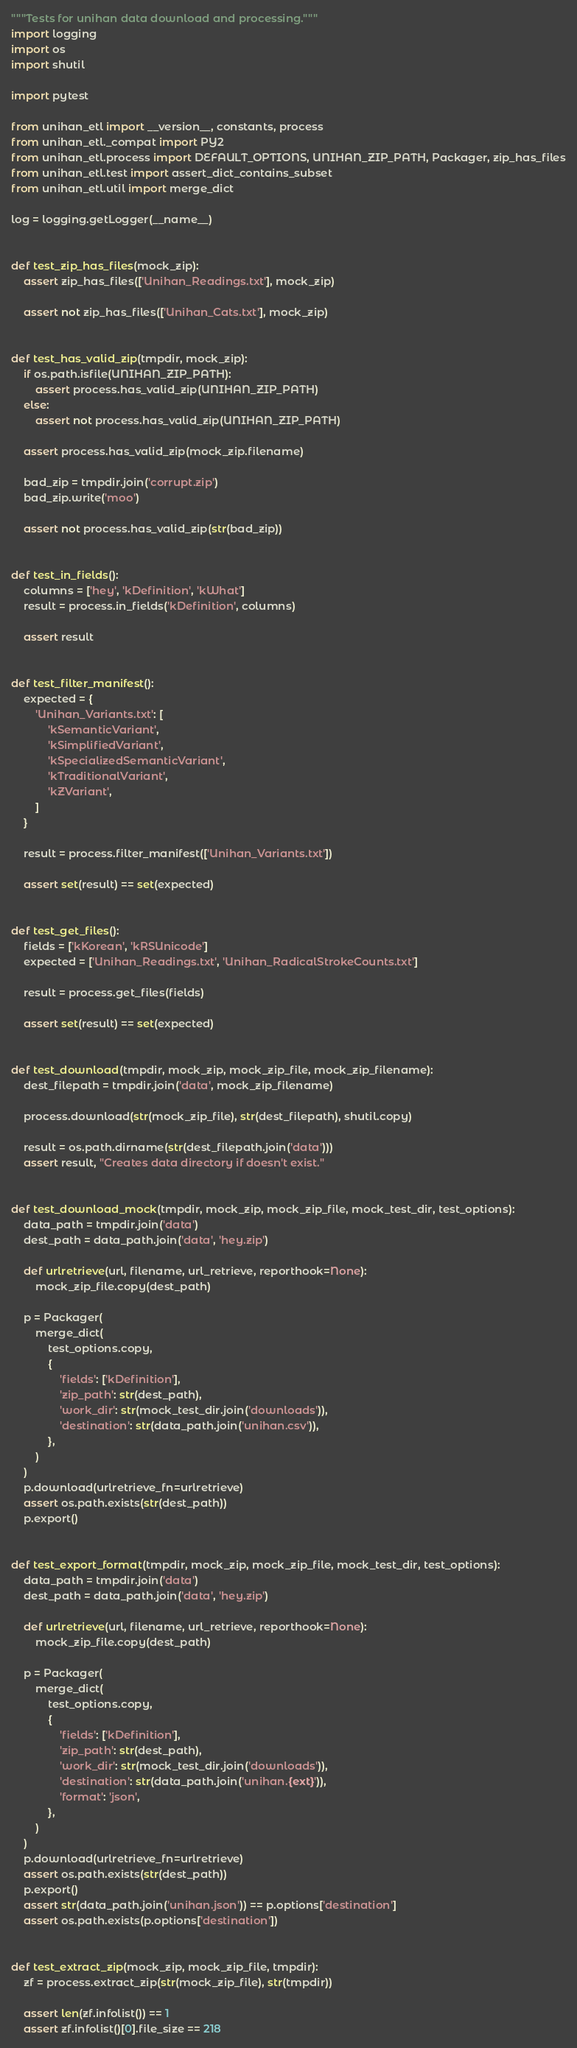Convert code to text. <code><loc_0><loc_0><loc_500><loc_500><_Python_>"""Tests for unihan data download and processing."""
import logging
import os
import shutil

import pytest

from unihan_etl import __version__, constants, process
from unihan_etl._compat import PY2
from unihan_etl.process import DEFAULT_OPTIONS, UNIHAN_ZIP_PATH, Packager, zip_has_files
from unihan_etl.test import assert_dict_contains_subset
from unihan_etl.util import merge_dict

log = logging.getLogger(__name__)


def test_zip_has_files(mock_zip):
    assert zip_has_files(['Unihan_Readings.txt'], mock_zip)

    assert not zip_has_files(['Unihan_Cats.txt'], mock_zip)


def test_has_valid_zip(tmpdir, mock_zip):
    if os.path.isfile(UNIHAN_ZIP_PATH):
        assert process.has_valid_zip(UNIHAN_ZIP_PATH)
    else:
        assert not process.has_valid_zip(UNIHAN_ZIP_PATH)

    assert process.has_valid_zip(mock_zip.filename)

    bad_zip = tmpdir.join('corrupt.zip')
    bad_zip.write('moo')

    assert not process.has_valid_zip(str(bad_zip))


def test_in_fields():
    columns = ['hey', 'kDefinition', 'kWhat']
    result = process.in_fields('kDefinition', columns)

    assert result


def test_filter_manifest():
    expected = {
        'Unihan_Variants.txt': [
            'kSemanticVariant',
            'kSimplifiedVariant',
            'kSpecializedSemanticVariant',
            'kTraditionalVariant',
            'kZVariant',
        ]
    }

    result = process.filter_manifest(['Unihan_Variants.txt'])

    assert set(result) == set(expected)


def test_get_files():
    fields = ['kKorean', 'kRSUnicode']
    expected = ['Unihan_Readings.txt', 'Unihan_RadicalStrokeCounts.txt']

    result = process.get_files(fields)

    assert set(result) == set(expected)


def test_download(tmpdir, mock_zip, mock_zip_file, mock_zip_filename):
    dest_filepath = tmpdir.join('data', mock_zip_filename)

    process.download(str(mock_zip_file), str(dest_filepath), shutil.copy)

    result = os.path.dirname(str(dest_filepath.join('data')))
    assert result, "Creates data directory if doesn't exist."


def test_download_mock(tmpdir, mock_zip, mock_zip_file, mock_test_dir, test_options):
    data_path = tmpdir.join('data')
    dest_path = data_path.join('data', 'hey.zip')

    def urlretrieve(url, filename, url_retrieve, reporthook=None):
        mock_zip_file.copy(dest_path)

    p = Packager(
        merge_dict(
            test_options.copy,
            {
                'fields': ['kDefinition'],
                'zip_path': str(dest_path),
                'work_dir': str(mock_test_dir.join('downloads')),
                'destination': str(data_path.join('unihan.csv')),
            },
        )
    )
    p.download(urlretrieve_fn=urlretrieve)
    assert os.path.exists(str(dest_path))
    p.export()


def test_export_format(tmpdir, mock_zip, mock_zip_file, mock_test_dir, test_options):
    data_path = tmpdir.join('data')
    dest_path = data_path.join('data', 'hey.zip')

    def urlretrieve(url, filename, url_retrieve, reporthook=None):
        mock_zip_file.copy(dest_path)

    p = Packager(
        merge_dict(
            test_options.copy,
            {
                'fields': ['kDefinition'],
                'zip_path': str(dest_path),
                'work_dir': str(mock_test_dir.join('downloads')),
                'destination': str(data_path.join('unihan.{ext}')),
                'format': 'json',
            },
        )
    )
    p.download(urlretrieve_fn=urlretrieve)
    assert os.path.exists(str(dest_path))
    p.export()
    assert str(data_path.join('unihan.json')) == p.options['destination']
    assert os.path.exists(p.options['destination'])


def test_extract_zip(mock_zip, mock_zip_file, tmpdir):
    zf = process.extract_zip(str(mock_zip_file), str(tmpdir))

    assert len(zf.infolist()) == 1
    assert zf.infolist()[0].file_size == 218</code> 